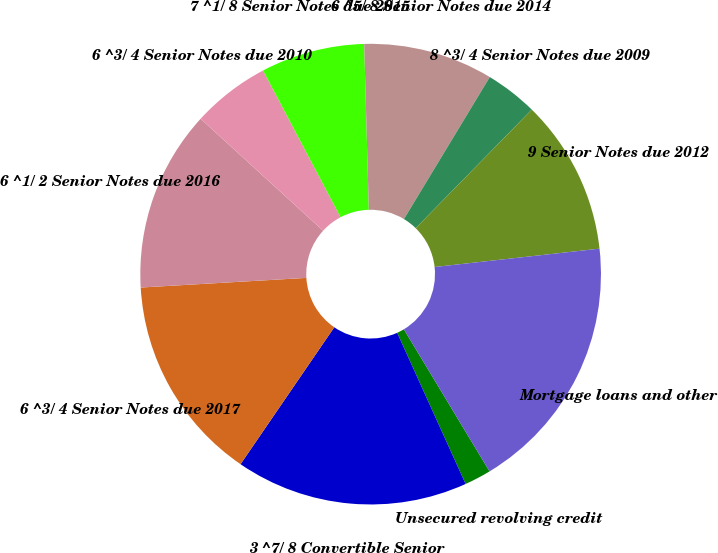<chart> <loc_0><loc_0><loc_500><loc_500><pie_chart><fcel>Unsecured revolving credit<fcel>3 ^7/ 8 Convertible Senior<fcel>6 ^3/ 4 Senior Notes due 2017<fcel>6 ^1/ 2 Senior Notes due 2016<fcel>6 ^3/ 4 Senior Notes due 2010<fcel>7 ^1/ 8 Senior Notes due 2015<fcel>6 ^5/ 8 Senior Notes due 2014<fcel>8 ^3/ 4 Senior Notes due 2009<fcel>9 Senior Notes due 2012<fcel>Mortgage loans and other<nl><fcel>1.87%<fcel>16.32%<fcel>14.52%<fcel>12.71%<fcel>5.48%<fcel>7.29%<fcel>9.1%<fcel>3.68%<fcel>10.9%<fcel>18.13%<nl></chart> 